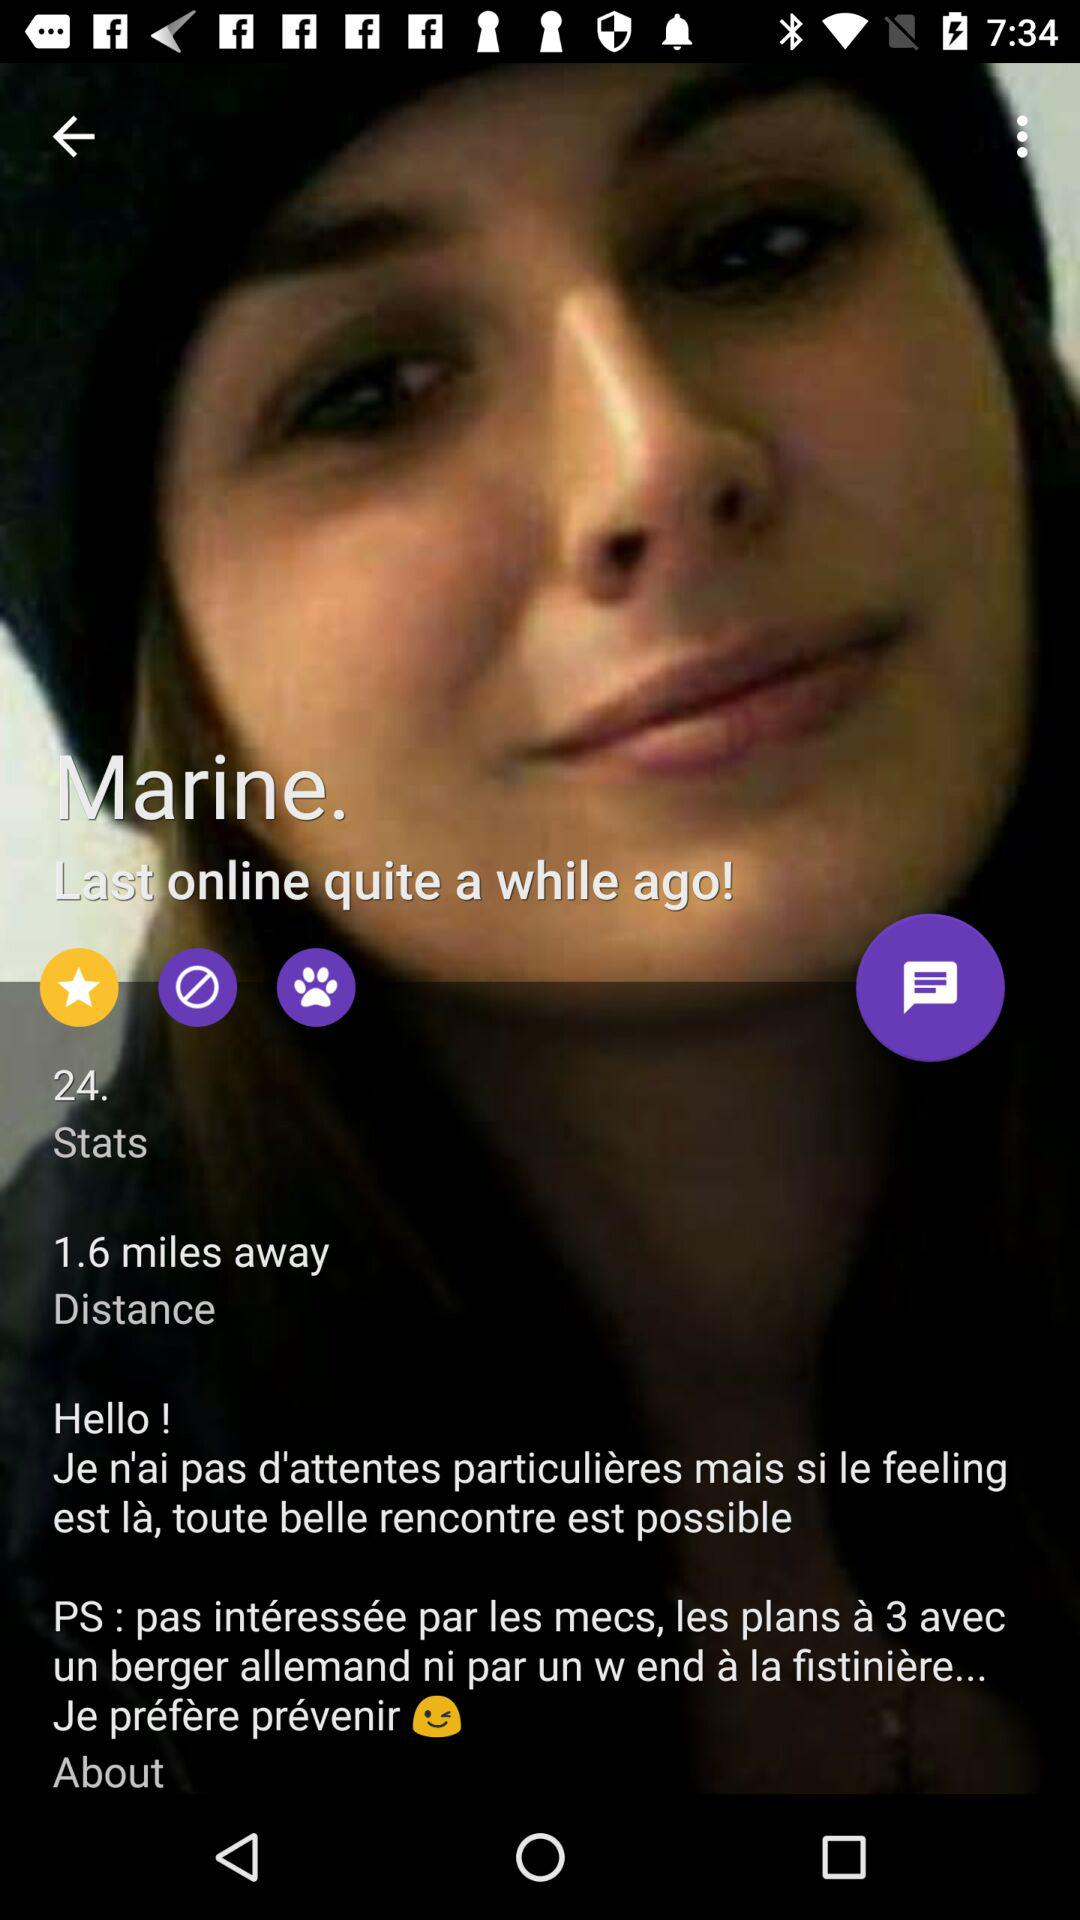What is the given age? The age is 24 years. 